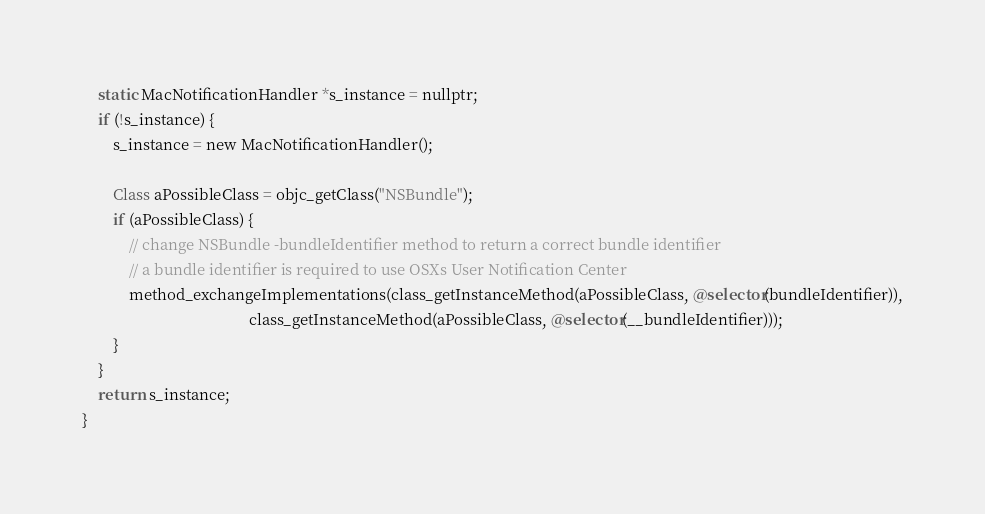<code> <loc_0><loc_0><loc_500><loc_500><_ObjectiveC_>    static MacNotificationHandler *s_instance = nullptr;
    if (!s_instance) {
        s_instance = new MacNotificationHandler();

        Class aPossibleClass = objc_getClass("NSBundle");
        if (aPossibleClass) {
            // change NSBundle -bundleIdentifier method to return a correct bundle identifier
            // a bundle identifier is required to use OSXs User Notification Center
            method_exchangeImplementations(class_getInstanceMethod(aPossibleClass, @selector(bundleIdentifier)),
                                           class_getInstanceMethod(aPossibleClass, @selector(__bundleIdentifier)));
        }
    }
    return s_instance;
}
</code> 